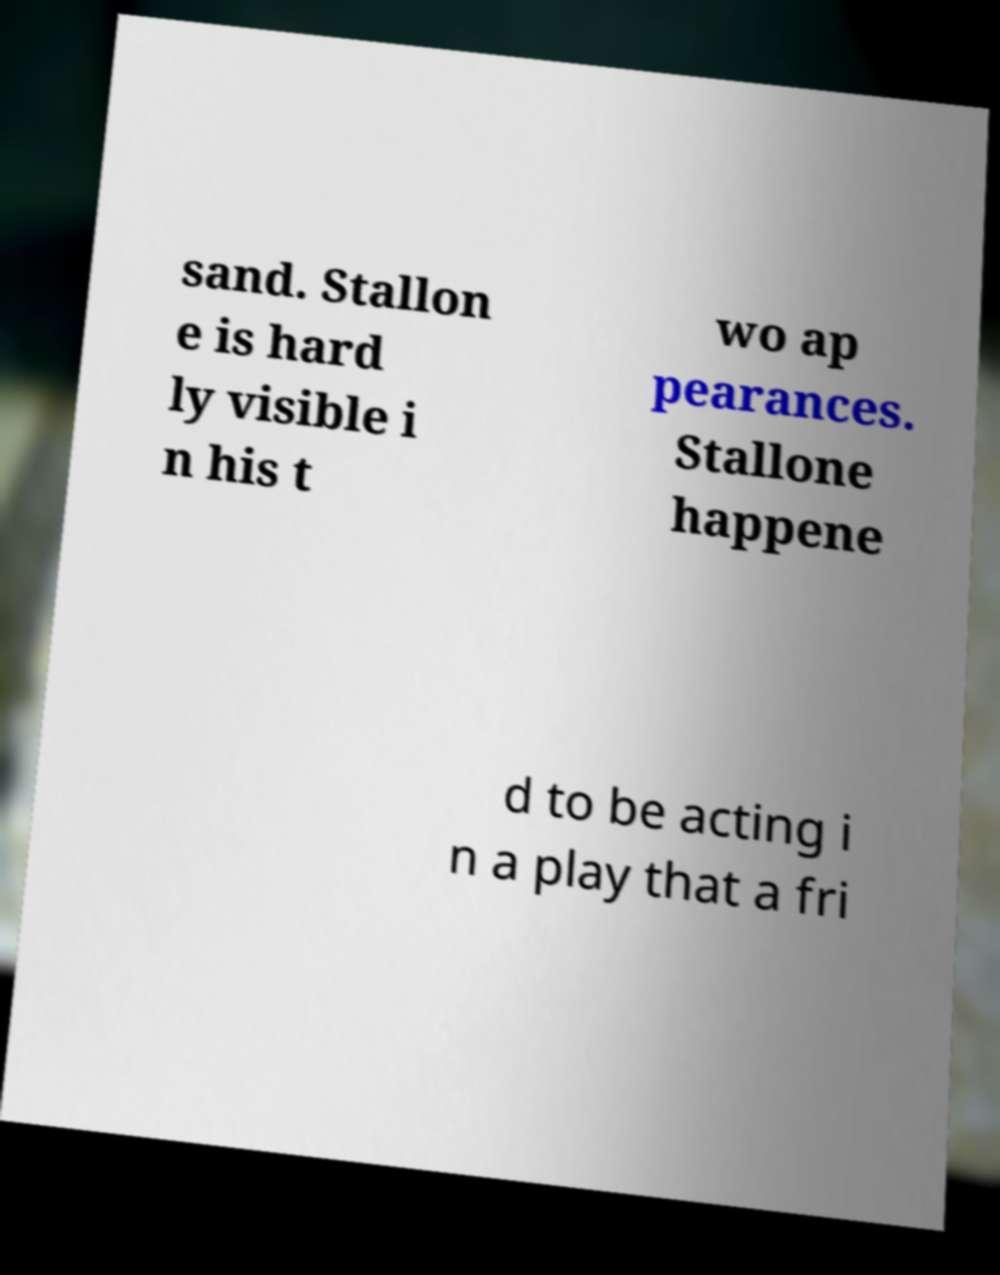I need the written content from this picture converted into text. Can you do that? sand. Stallon e is hard ly visible i n his t wo ap pearances. Stallone happene d to be acting i n a play that a fri 